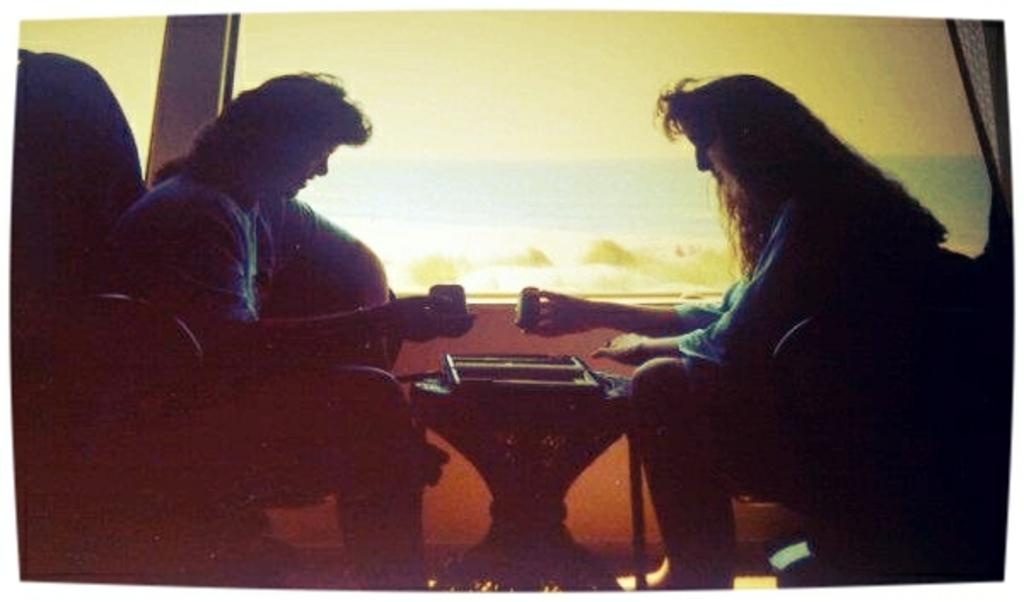How many people are present in the image? There are two people in the image, a man and a woman. What are the man and woman doing in the image? The man and woman are sitting on chairs. How many houses can be seen on the hill in the image? There is no hill or houses present in the image; it features a man and a woman sitting on chairs. What type of ducks are swimming in the pond in the image? There is no pond or ducks present in the image. 